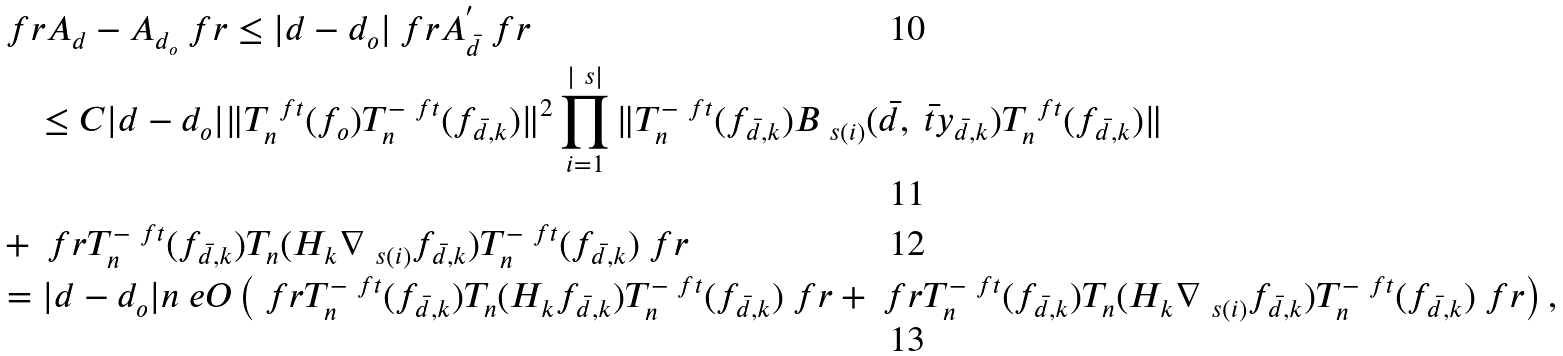Convert formula to latex. <formula><loc_0><loc_0><loc_500><loc_500>& \ f r A _ { d } - A _ { d _ { o } } \ f r \leq | d - d _ { o } | \ f r A _ { \bar { d } } ^ { ^ { \prime } } \ f r \\ & \quad \leq C | d - d _ { o } | \| T _ { n } ^ { \ f t } ( f _ { o } ) T _ { n } ^ { - \ f t } ( f _ { \bar { d } , k } ) \| ^ { 2 } \prod _ { i = 1 } ^ { | \ s | } \| T _ { n } ^ { - \ f t } ( f _ { \bar { d } , k } ) B _ { \ s ( i ) } ( \bar { d } , \bar { \ t y } _ { \bar { d } , k } ) T _ { n } ^ { \ f t } ( f _ { \bar { d } , k } ) \| \\ & + \ f r T _ { n } ^ { - \ f t } ( f _ { \bar { d } , k } ) T _ { n } ( H _ { k } \nabla _ { \ s ( i ) } f _ { \bar { d } , k } ) T _ { n } ^ { - \ f t } ( f _ { \bar { d } , k } ) \ f r \\ & = | d - d _ { o } | n ^ { \ } e O \left ( \ f r T _ { n } ^ { - \ f t } ( f _ { \bar { d } , k } ) T _ { n } ( H _ { k } f _ { \bar { d } , k } ) T _ { n } ^ { - \ f t } ( f _ { \bar { d } , k } ) \ f r + \ f r T _ { n } ^ { - \ f t } ( f _ { \bar { d } , k } ) T _ { n } ( H _ { k } \nabla _ { \ s ( i ) } f _ { \bar { d } , k } ) T _ { n } ^ { - \ f t } ( f _ { \bar { d } , k } ) \ f r \right ) ,</formula> 